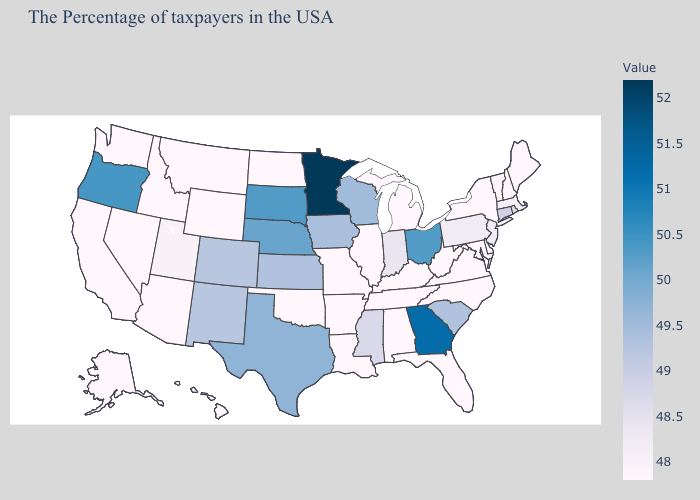Does New Mexico have the highest value in the USA?
Give a very brief answer. No. Among the states that border New Hampshire , which have the lowest value?
Answer briefly. Maine, Vermont. Which states have the highest value in the USA?
Concise answer only. Minnesota. Which states hav the highest value in the Northeast?
Be succinct. Connecticut. Does New Jersey have the lowest value in the USA?
Be succinct. No. 